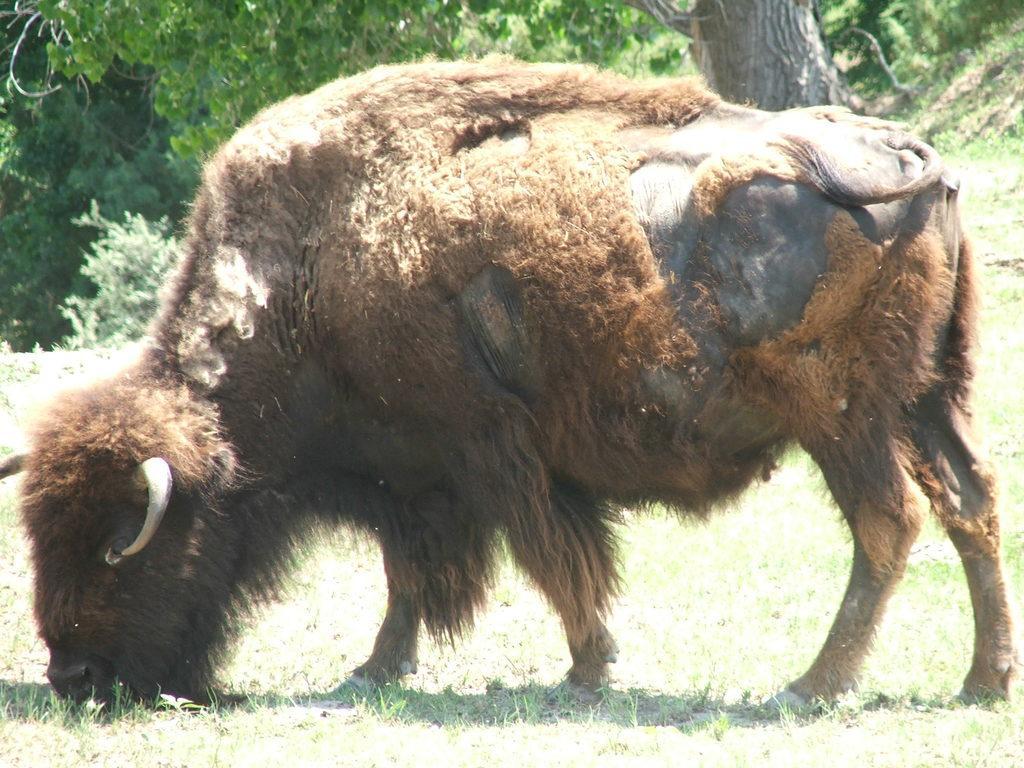Please provide a concise description of this image. In this image, we can see an animal on the grass. Background we can see tree trunk and plants. 